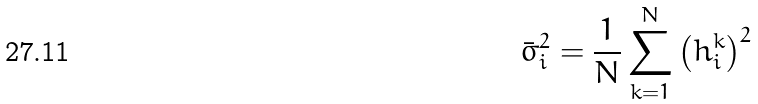Convert formula to latex. <formula><loc_0><loc_0><loc_500><loc_500>\bar { \sigma } ^ { 2 } _ { i } = \frac { 1 } { N } \sum _ { k = 1 } ^ { N } \left ( h _ { i } ^ { k } \right ) ^ { 2 }</formula> 